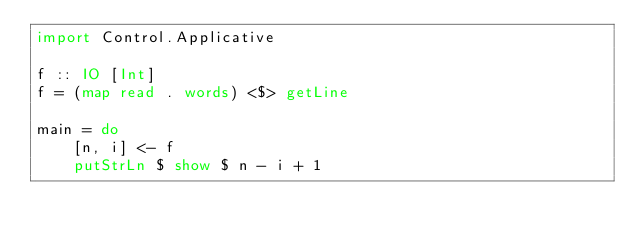Convert code to text. <code><loc_0><loc_0><loc_500><loc_500><_Haskell_>import Control.Applicative

f :: IO [Int]
f = (map read . words) <$> getLine

main = do
    [n, i] <- f
    putStrLn $ show $ n - i + 1
</code> 